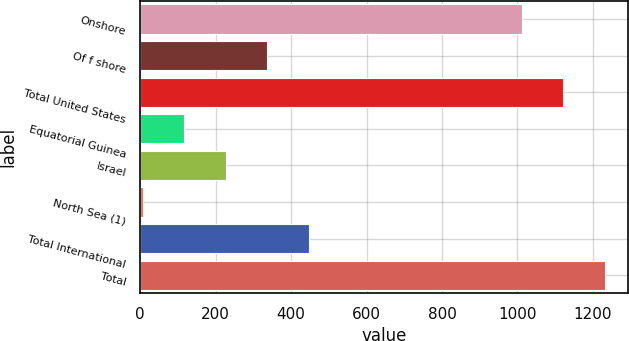<chart> <loc_0><loc_0><loc_500><loc_500><bar_chart><fcel>Onshore<fcel>Of f shore<fcel>Total United States<fcel>Equatorial Guinea<fcel>Israel<fcel>North Sea (1)<fcel>Total International<fcel>Total<nl><fcel>1012<fcel>336.7<fcel>1121.9<fcel>116.9<fcel>226.8<fcel>7<fcel>446.6<fcel>1231.8<nl></chart> 